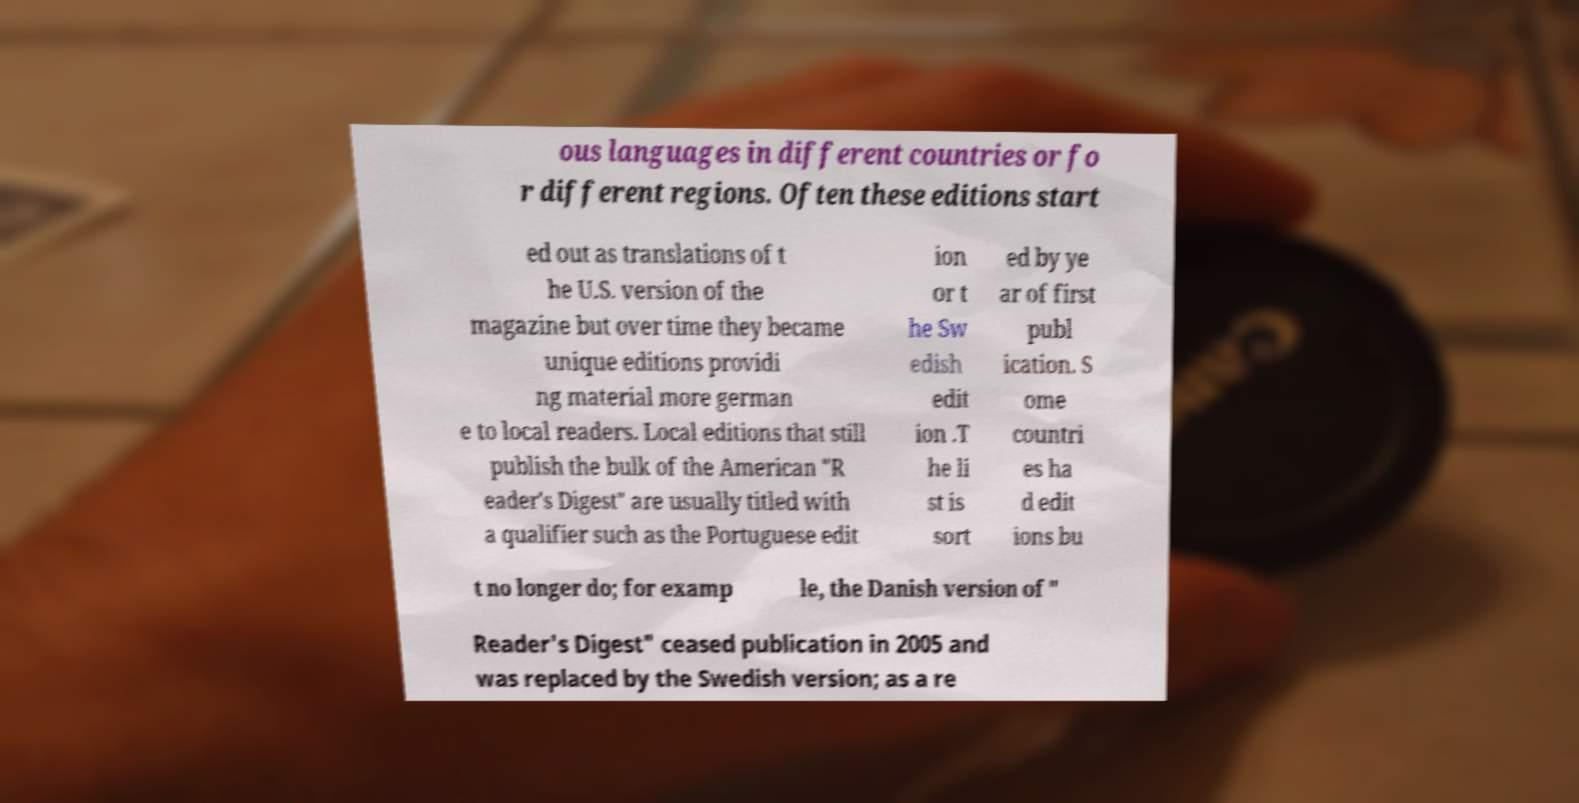Could you assist in decoding the text presented in this image and type it out clearly? ous languages in different countries or fo r different regions. Often these editions start ed out as translations of t he U.S. version of the magazine but over time they became unique editions providi ng material more german e to local readers. Local editions that still publish the bulk of the American "R eader's Digest" are usually titled with a qualifier such as the Portuguese edit ion or t he Sw edish edit ion .T he li st is sort ed by ye ar of first publ ication. S ome countri es ha d edit ions bu t no longer do; for examp le, the Danish version of " Reader's Digest" ceased publication in 2005 and was replaced by the Swedish version; as a re 